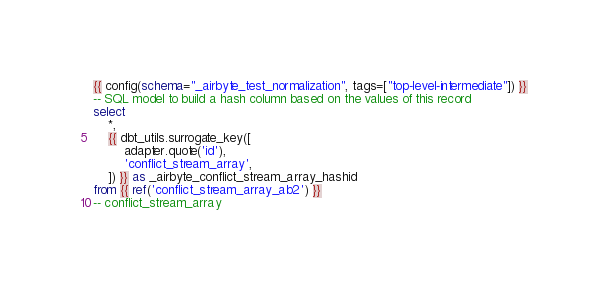Convert code to text. <code><loc_0><loc_0><loc_500><loc_500><_SQL_>{{ config(schema="_airbyte_test_normalization", tags=["top-level-intermediate"]) }}
-- SQL model to build a hash column based on the values of this record
select
    *,
    {{ dbt_utils.surrogate_key([
        adapter.quote('id'),
        'conflict_stream_array',
    ]) }} as _airbyte_conflict_stream_array_hashid
from {{ ref('conflict_stream_array_ab2') }}
-- conflict_stream_array

</code> 